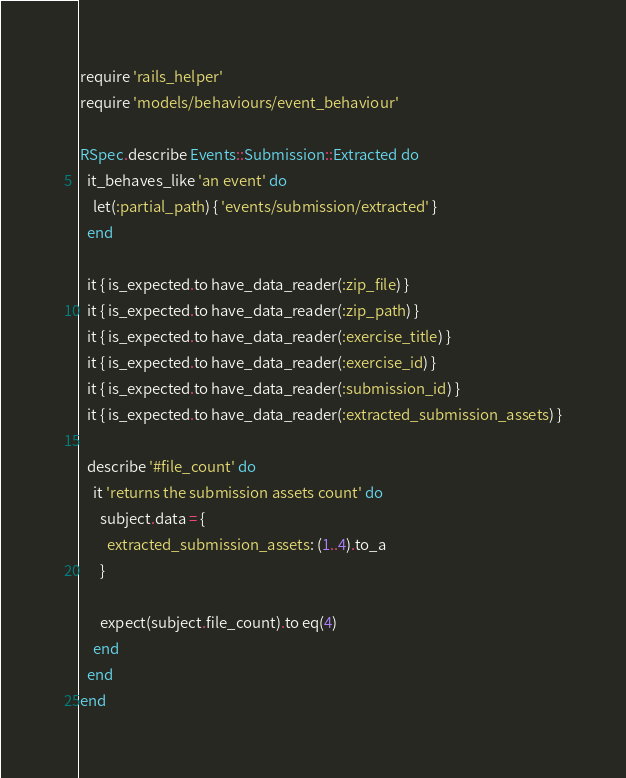<code> <loc_0><loc_0><loc_500><loc_500><_Ruby_>require 'rails_helper'
require 'models/behaviours/event_behaviour'

RSpec.describe Events::Submission::Extracted do
  it_behaves_like 'an event' do
    let(:partial_path) { 'events/submission/extracted' }
  end

  it { is_expected.to have_data_reader(:zip_file) }
  it { is_expected.to have_data_reader(:zip_path) }
  it { is_expected.to have_data_reader(:exercise_title) }
  it { is_expected.to have_data_reader(:exercise_id) }
  it { is_expected.to have_data_reader(:submission_id) }
  it { is_expected.to have_data_reader(:extracted_submission_assets) }

  describe '#file_count' do
    it 'returns the submission assets count' do
      subject.data = {
        extracted_submission_assets: (1..4).to_a
      }

      expect(subject.file_count).to eq(4)
    end
  end
end
</code> 